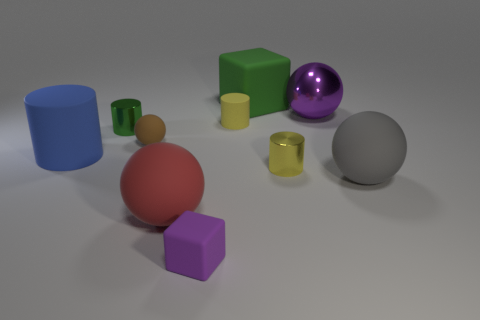Subtract all gray spheres. How many yellow cylinders are left? 2 Subtract all small balls. How many balls are left? 3 Subtract all red spheres. How many spheres are left? 3 Subtract all green cylinders. Subtract all blue cubes. How many cylinders are left? 3 Add 3 large shiny things. How many large shiny things exist? 4 Subtract 1 gray balls. How many objects are left? 9 Subtract all spheres. How many objects are left? 6 Subtract all matte objects. Subtract all small purple matte things. How many objects are left? 2 Add 8 brown objects. How many brown objects are left? 9 